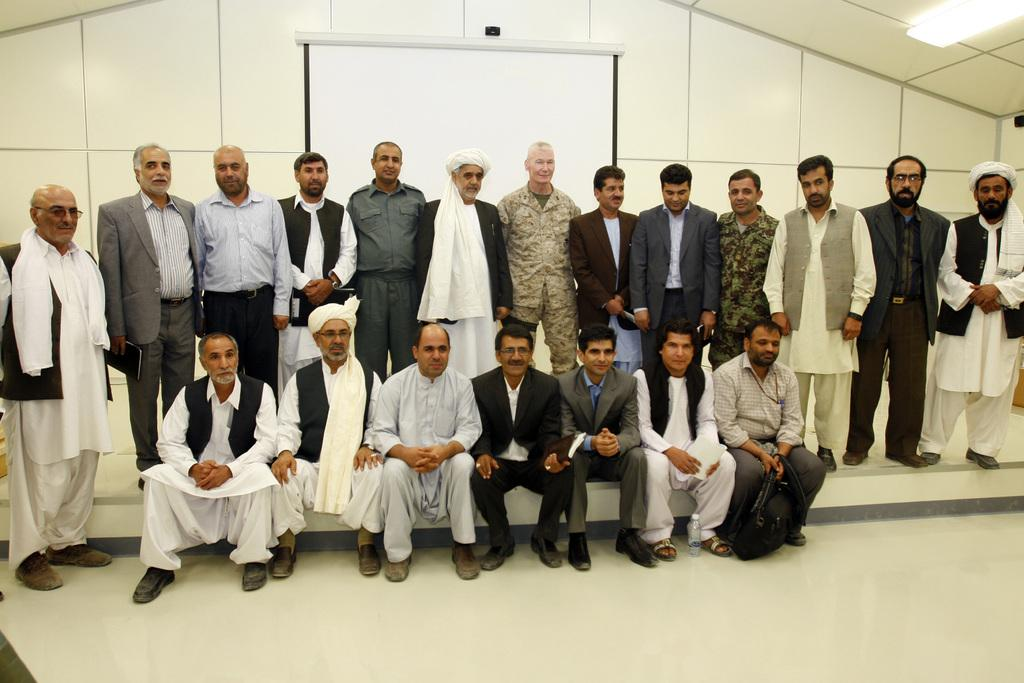What types of people are present in the image? There are men standing and women standing and sitting in the image. What is the background of the image? They are in front of a white wall. What is on the white wall? There is a board in the middle of the white wall. What can be seen on the ceiling in the image? There are lights on the ceiling. What type of arch can be seen in the image? There is no arch present in the image. What rule are the people following in the image? There is no specific rule being followed by the people in the image. 